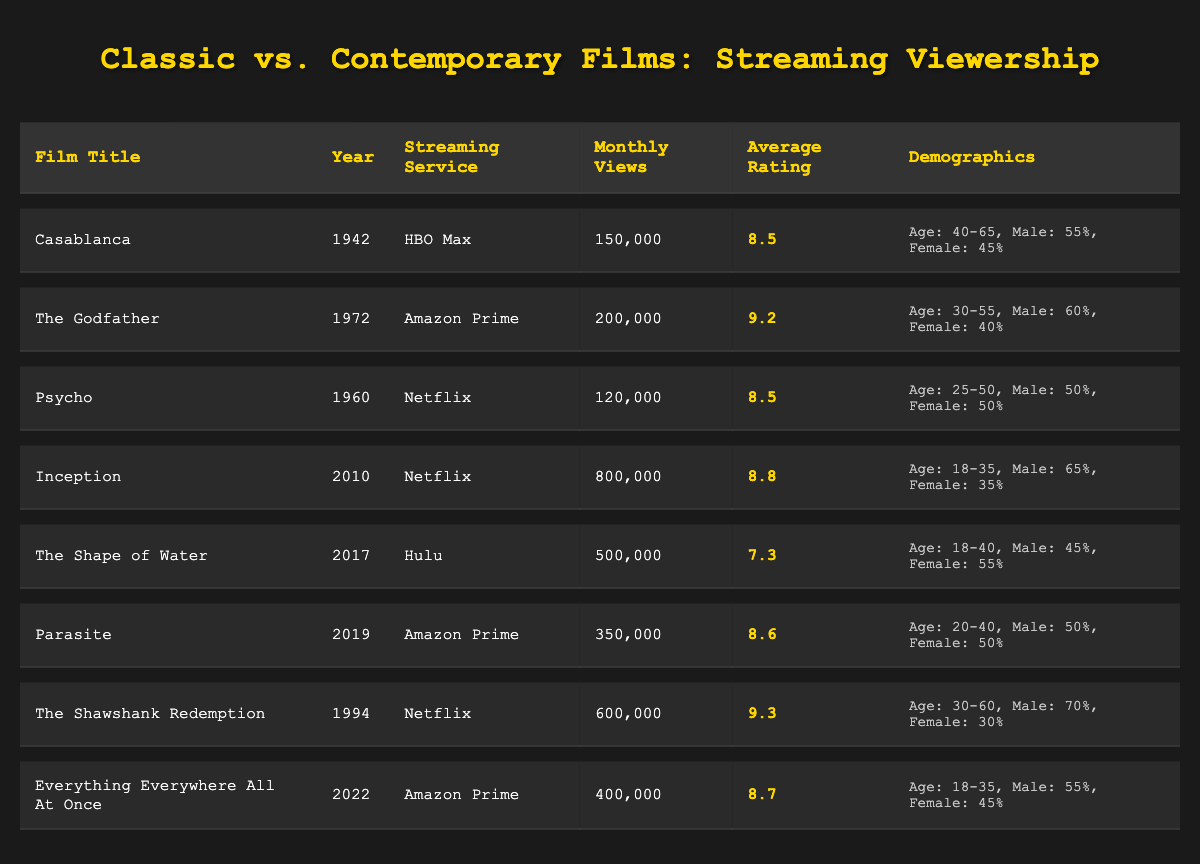What is the monthly view count for "Casablanca"? The table lists the monthly views for "Casablanca" as 150,000 under the monthly views column.
Answer: 150,000 Which film has the highest average rating? In the table, "The Godfather" has the highest average rating at 9.2, which can be found in the average rating column.
Answer: 9.2 How many views does "Inception" have compared to "Psycho"? "Inception" has 800,000 monthly views and "Psycho" has 120,000 monthly views. The difference is calculated as 800,000 - 120,000 = 680,000.
Answer: 680,000 True or False: "The Shape of Water" has more monthly views than "The Shawshank Redemption." "The Shape of Water" has 500,000 monthly views while "The Shawshank Redemption" has 600,000 views. Since 500,000 is less than 600,000, the statement is false.
Answer: False What is the combined total of monthly views for all classic films listed? The classic films listed are "Casablanca" (150,000), "The Godfather" (200,000), "Psycho" (120,000), and "The Shawshank Redemption" (600,000). Adding those values gives 150,000 + 200,000 + 120,000 + 600,000 = 1,070,000.
Answer: 1,070,000 Which streaming service has the most films listed? The table lists films from HBO Max, Amazon Prime, Netflix, and Hulu. By counting, HBO Max has 1, Amazon Prime has 2, Netflix has 3, and Hulu has 1. Netflix has the most with 3 films listed.
Answer: Netflix What is the average age demographic for contemporary films listed? The contemporary films are "Inception" (18-35), "The Shape of Water" (18-40), "Parasite" (20-40), and "Everything Everywhere All At Once" (18-35). A range can be calculated, combining them leads to 18 to 40, so the average range is from 18 to 40.
Answer: 18-40 Is the gender distribution for "The Shawshank Redemption" skewed towards males? The gender distribution for "The Shawshank Redemption" is 70% male and 30% female. Since 70% is greater than 50%, this indicates a skew towards males.
Answer: Yes 